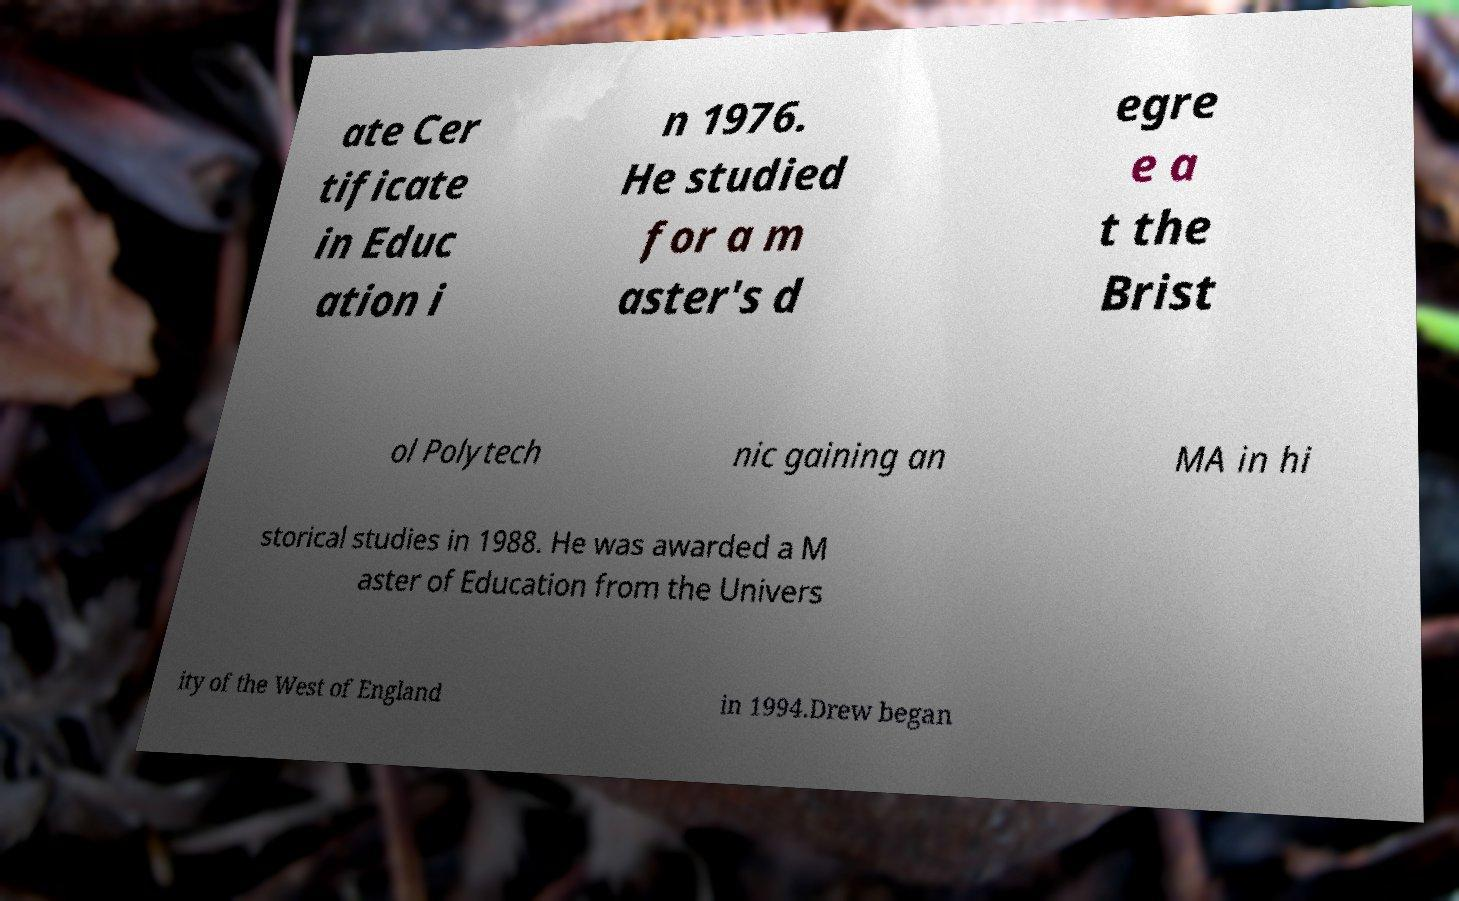There's text embedded in this image that I need extracted. Can you transcribe it verbatim? ate Cer tificate in Educ ation i n 1976. He studied for a m aster's d egre e a t the Brist ol Polytech nic gaining an MA in hi storical studies in 1988. He was awarded a M aster of Education from the Univers ity of the West of England in 1994.Drew began 